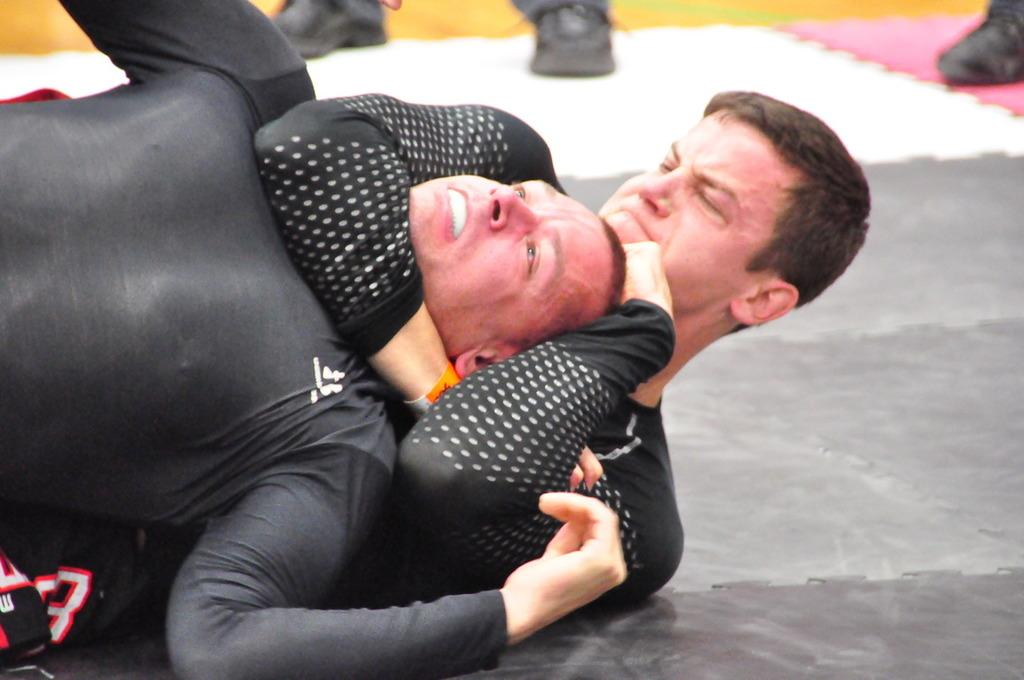How many people are in the image? There are two persons in the image. What are the two persons doing in the image? The two persons are fighting on the floor. Can you describe any body parts visible in the image? There are visible legs of at least one person in the image. What is the distribution of heat in the image? There is no information about heat distribution in the image, as it focuses on the two persons fighting on the floor. 